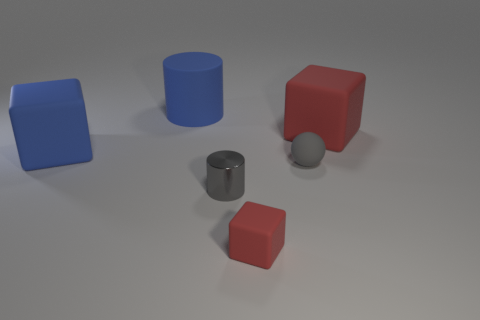How many cylinders are large red rubber objects or gray rubber things?
Ensure brevity in your answer.  0. How many other things are the same material as the big red cube?
Your response must be concise. 4. What is the shape of the red matte object that is behind the blue cube?
Your response must be concise. Cube. What material is the red block on the right side of the red rubber block in front of the small cylinder?
Give a very brief answer. Rubber. Are there more small red rubber blocks that are to the right of the gray rubber object than gray metal cylinders?
Provide a succinct answer. No. There is a shiny thing that is the same size as the gray matte thing; what is its shape?
Keep it short and to the point. Cylinder. What number of objects are behind the small thing that is to the left of the red matte cube that is in front of the small gray cylinder?
Your answer should be very brief. 4. How many matte things are gray cylinders or big gray cylinders?
Your response must be concise. 0. There is a tiny thing that is both right of the metal cylinder and in front of the gray sphere; what is its color?
Your response must be concise. Red. Do the gray sphere behind the metal cylinder and the large blue cube have the same size?
Provide a succinct answer. No. 